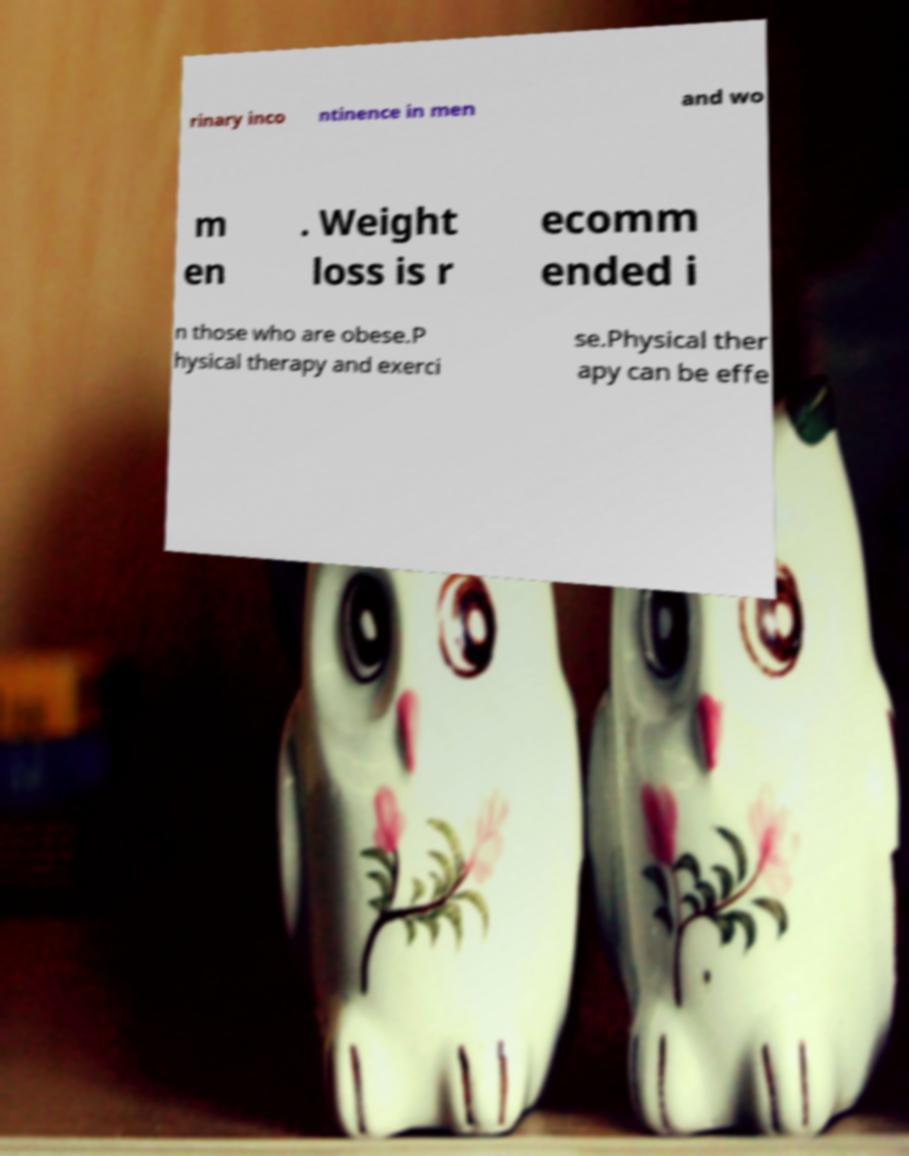Please read and relay the text visible in this image. What does it say? rinary inco ntinence in men and wo m en . Weight loss is r ecomm ended i n those who are obese.P hysical therapy and exerci se.Physical ther apy can be effe 